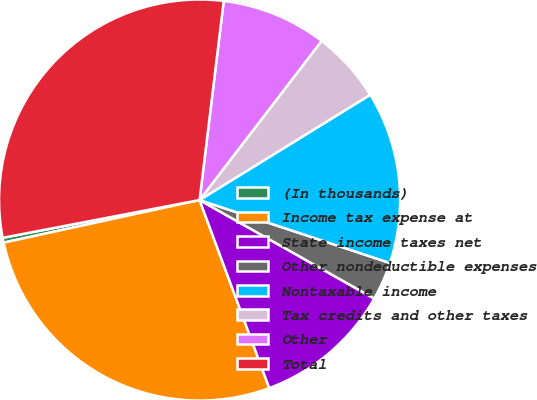Convert chart. <chart><loc_0><loc_0><loc_500><loc_500><pie_chart><fcel>(In thousands)<fcel>Income tax expense at<fcel>State income taxes net<fcel>Other nondeductible expenses<fcel>Nontaxable income<fcel>Tax credits and other taxes<fcel>Other<fcel>Total<nl><fcel>0.39%<fcel>27.24%<fcel>11.18%<fcel>3.09%<fcel>13.88%<fcel>5.79%<fcel>8.49%<fcel>29.94%<nl></chart> 